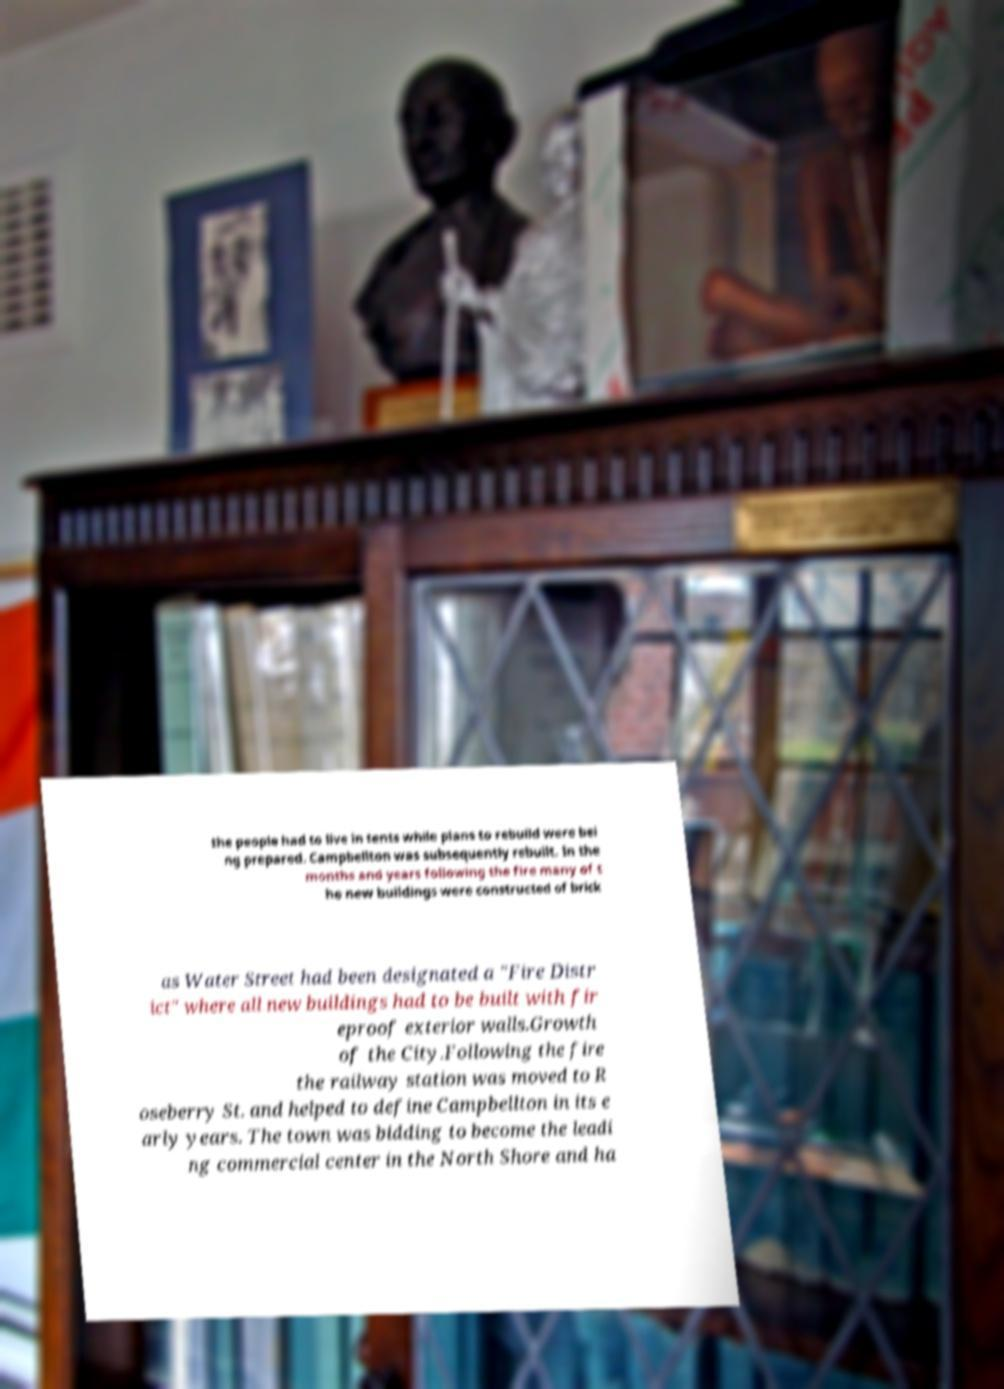Please read and relay the text visible in this image. What does it say? the people had to live in tents while plans to rebuild were bei ng prepared. Campbellton was subsequently rebuilt. In the months and years following the fire many of t he new buildings were constructed of brick as Water Street had been designated a "Fire Distr ict" where all new buildings had to be built with fir eproof exterior walls.Growth of the City.Following the fire the railway station was moved to R oseberry St. and helped to define Campbellton in its e arly years. The town was bidding to become the leadi ng commercial center in the North Shore and ha 